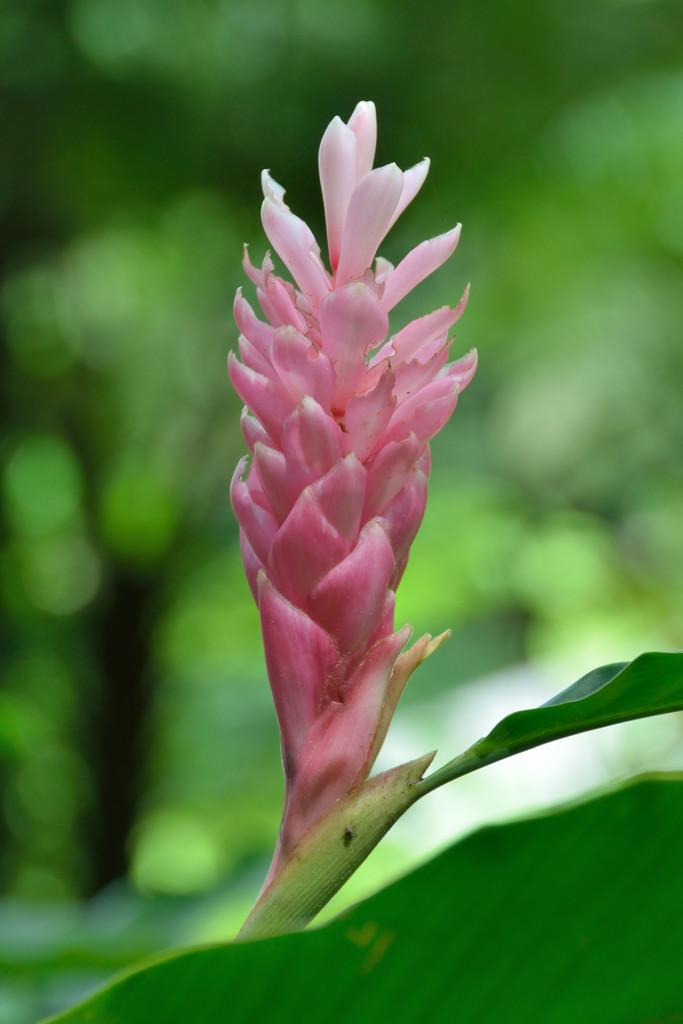What type of living organisms can be seen in the image? There are flowers and plants visible in the image. Can you describe the background of the image? The background of the image is blurred. Where is the faucet located in the image? There is no faucet present in the image. What type of space object can be seen in the image? There are no space objects present in the image; it features flowers and plants. 